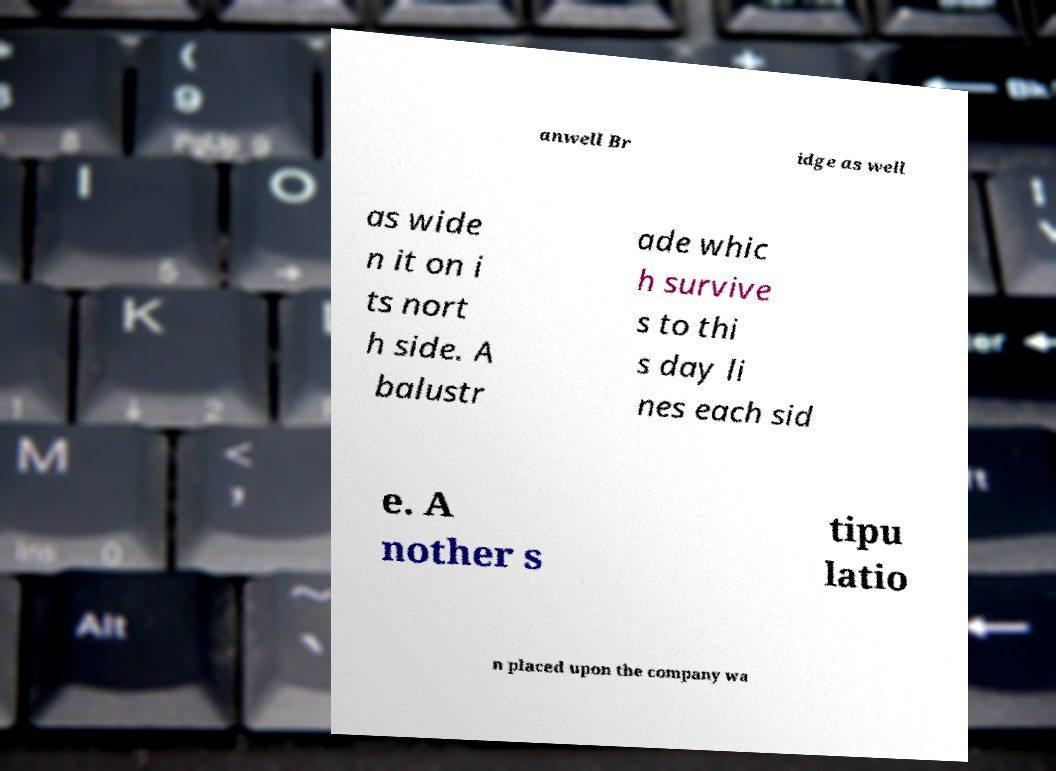Could you extract and type out the text from this image? anwell Br idge as well as wide n it on i ts nort h side. A balustr ade whic h survive s to thi s day li nes each sid e. A nother s tipu latio n placed upon the company wa 